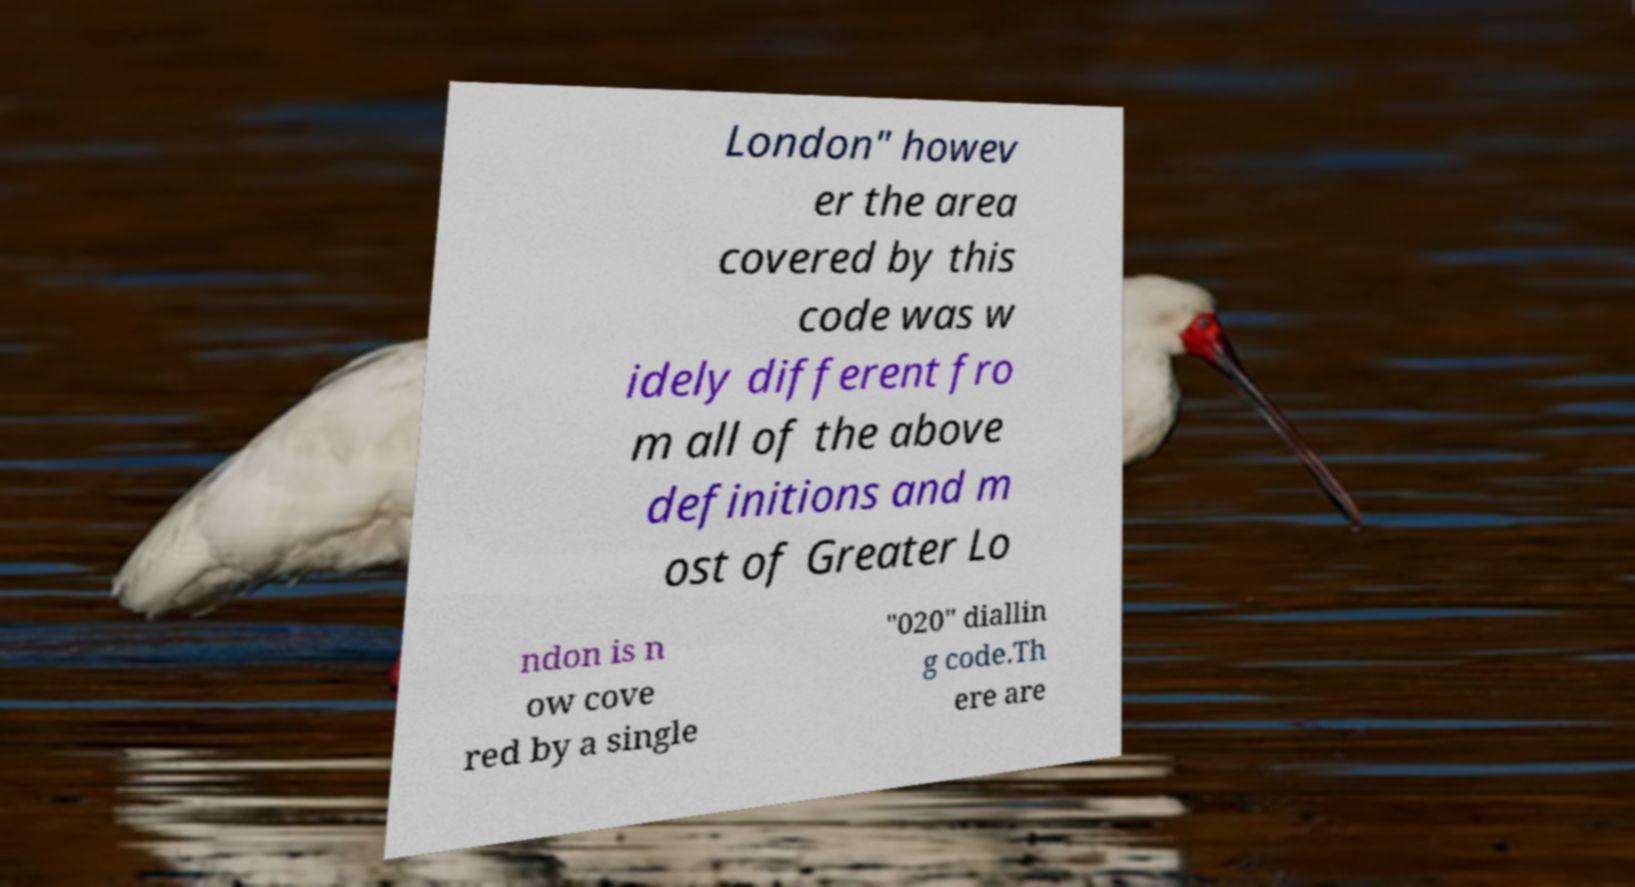Please identify and transcribe the text found in this image. London" howev er the area covered by this code was w idely different fro m all of the above definitions and m ost of Greater Lo ndon is n ow cove red by a single "020" diallin g code.Th ere are 